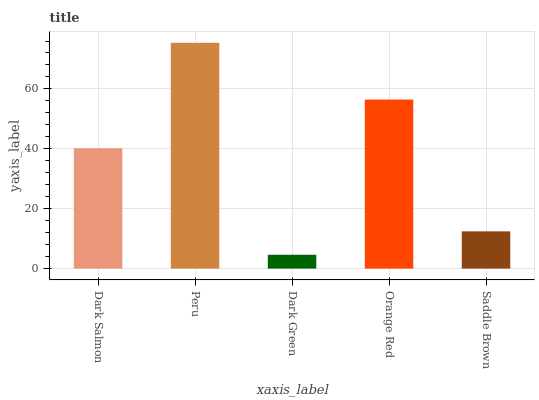Is Dark Green the minimum?
Answer yes or no. Yes. Is Peru the maximum?
Answer yes or no. Yes. Is Peru the minimum?
Answer yes or no. No. Is Dark Green the maximum?
Answer yes or no. No. Is Peru greater than Dark Green?
Answer yes or no. Yes. Is Dark Green less than Peru?
Answer yes or no. Yes. Is Dark Green greater than Peru?
Answer yes or no. No. Is Peru less than Dark Green?
Answer yes or no. No. Is Dark Salmon the high median?
Answer yes or no. Yes. Is Dark Salmon the low median?
Answer yes or no. Yes. Is Dark Green the high median?
Answer yes or no. No. Is Dark Green the low median?
Answer yes or no. No. 